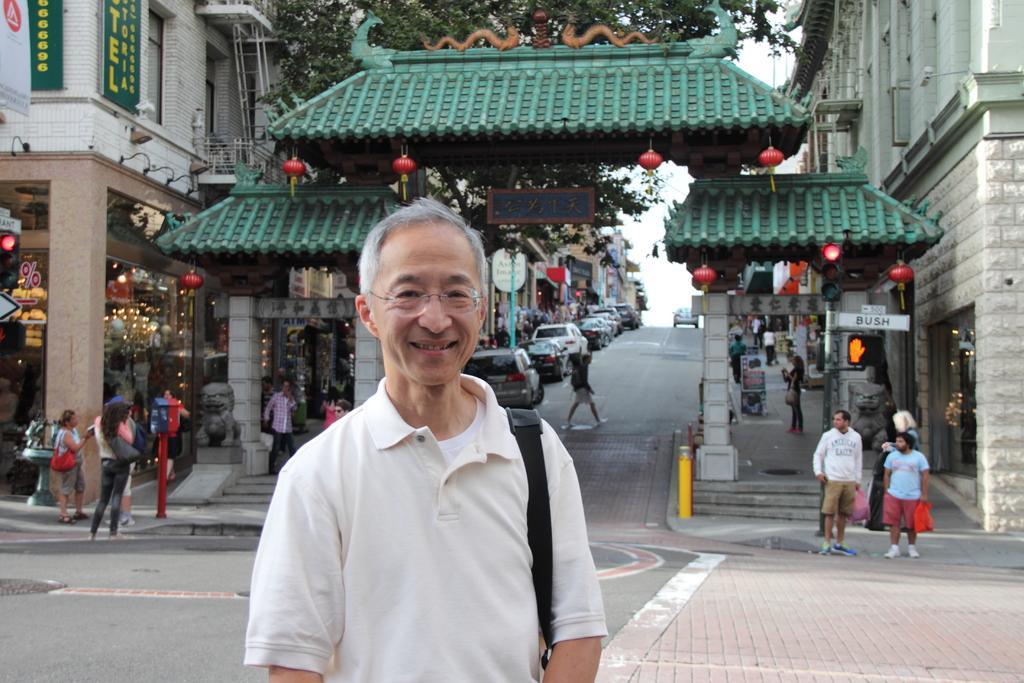Describe this image in one or two sentences. In the foreground of this image, there is a man wearing a bag and posing to a camera. In the background, there is an entrance arch, few people standing and walking on the side path, and building on either side to the road. We can also see few vehicles on the road. At the top, there is the sky and a tree. 